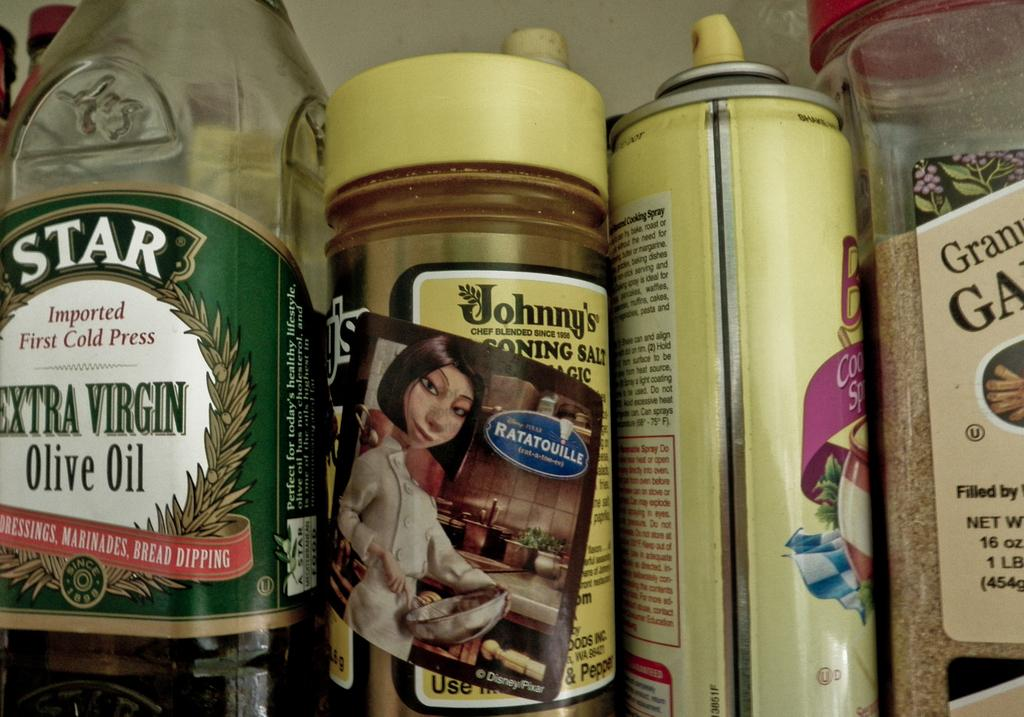<image>
Present a compact description of the photo's key features. A collection of kitchen items including Star brand extra virgin olive oil. 